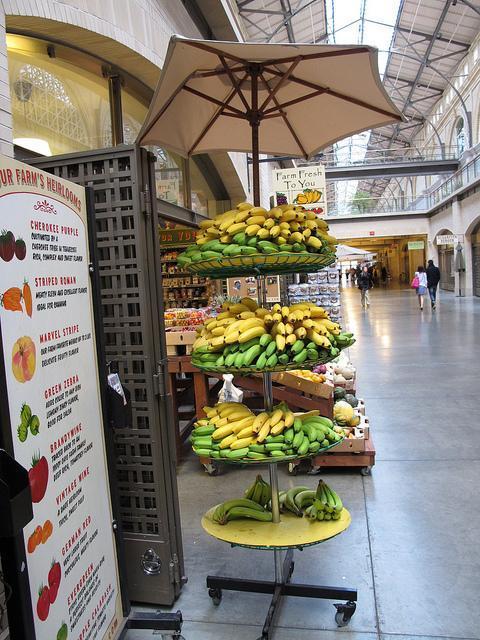How many bananas can be seen?
Give a very brief answer. 4. 